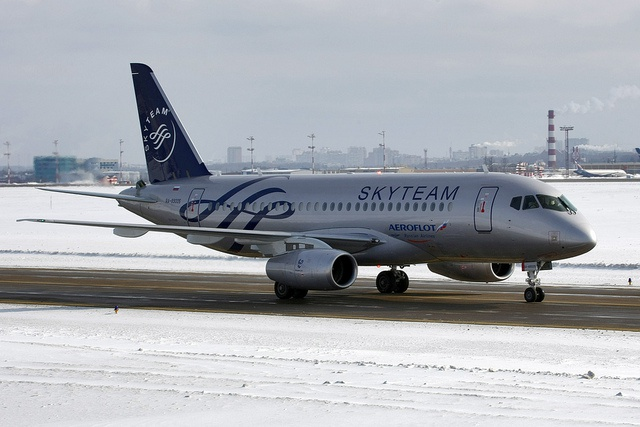Describe the objects in this image and their specific colors. I can see airplane in lightgray, black, gray, and darkgray tones, airplane in lightgray, darkgray, gray, and darkblue tones, people in lightgray, black, gray, and darkgray tones, and people in black, darkblue, and lightgray tones in this image. 